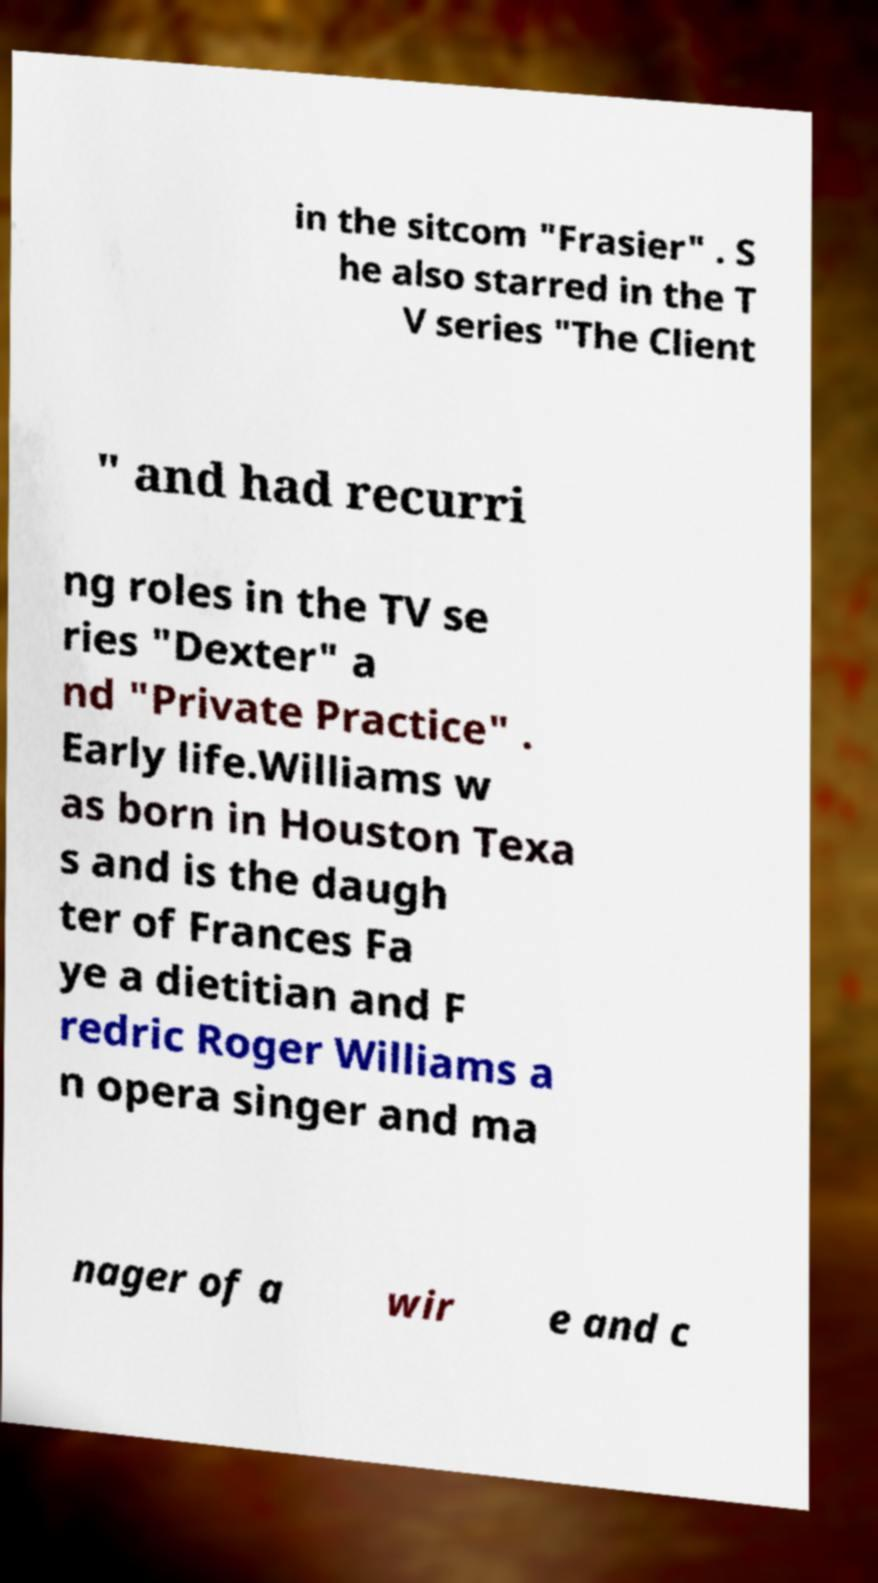Could you extract and type out the text from this image? in the sitcom "Frasier" . S he also starred in the T V series "The Client " and had recurri ng roles in the TV se ries "Dexter" a nd "Private Practice" . Early life.Williams w as born in Houston Texa s and is the daugh ter of Frances Fa ye a dietitian and F redric Roger Williams a n opera singer and ma nager of a wir e and c 